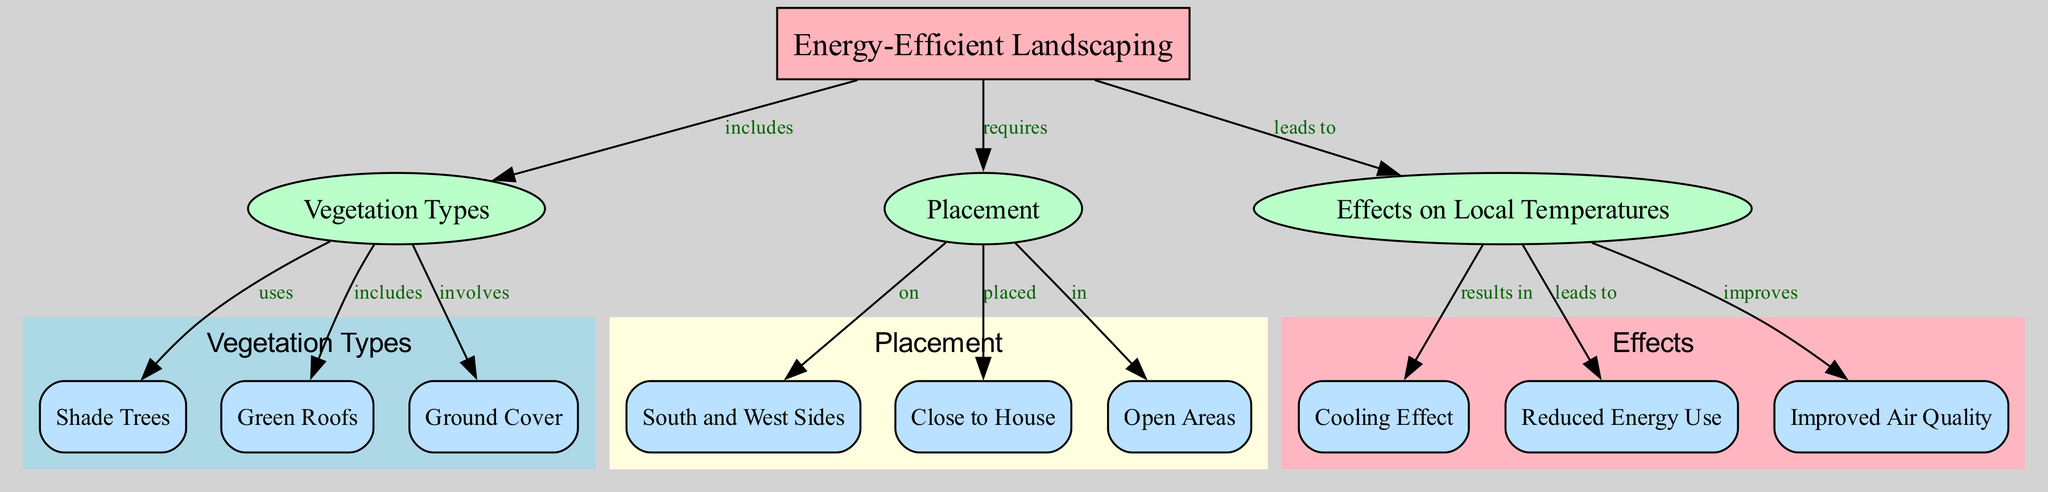What is the main focus of the diagram? The diagram is centered around "Energy-Efficient Landscaping," which is represented as the main node at the top of the diagram.
Answer: Energy-Efficient Landscaping How many category nodes are there in the diagram? There are three category nodes: "Vegetation Types," "Placement," and "Effects on Local Temperatures." Therefore, counting these three categories gives a total of three.
Answer: 3 What type of vegetation is indicated as using in the diagram? The diagram indicates "Shade Trees," which is listed as one of the vegetation types under the "Vegetation Types" category.
Answer: Shade Trees Which sides of the house should be targeted for placement according to the diagram? The diagram identifies the "South and West Sides" as the optimal areas for placing vegetation.
Answer: South and West Sides What is the final effect of implementing landscaping in terms of local temperature? The final effect shown in the diagram for local temperatures as a result of landscaping strategies is a "Cooling Effect." This indicates that these strategies are aimed at lowering local temperatures.
Answer: Cooling Effect What leads to improved air quality according to the diagram? The diagram shows that the "Effects on Local Temperatures" lead to "Improved Air Quality," indicating a direct relationship between the outcomes of landscaping and air quality.
Answer: Improved Air Quality What elements are involved in energy-efficient landscaping? The elements involved in energy-efficient landscaping include "Shade Trees," "Green Roofs," and "Ground Cover," which are detailed as part of the "Vegetation Types" category.
Answer: Shade Trees, Green Roofs, Ground Cover What are the potential benefits of reduced energy use shown in the diagram? The benefits of "Reduced Energy Use" as a result of landscaping strategies are indicated to be an outcome of improved local temperatures, hence reflecting a reduction in energy consumption as a direct relation.
Answer: Improved Local Temperatures In how many areas should landscaping be placed according to the diagram? The diagram outlines three areas for placement: "South and West Sides," "Close to House," and "Open Areas." This gives a total of three specific placement areas highlighted for effective landscaping.
Answer: 3 